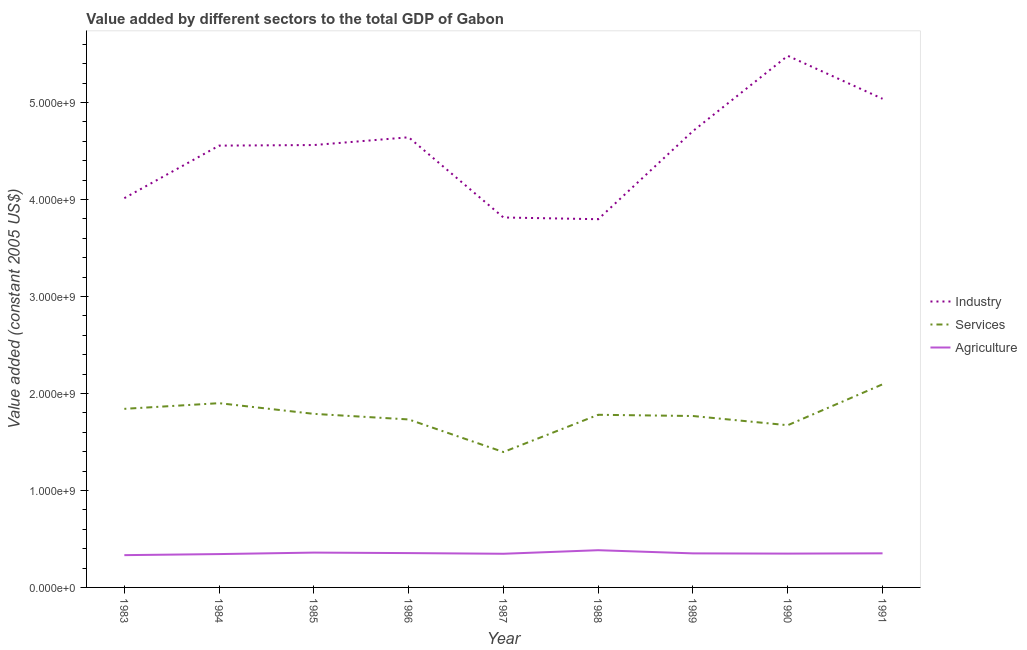How many different coloured lines are there?
Your answer should be compact. 3. What is the value added by services in 1984?
Your answer should be very brief. 1.90e+09. Across all years, what is the maximum value added by services?
Offer a terse response. 2.09e+09. Across all years, what is the minimum value added by industrial sector?
Offer a terse response. 3.80e+09. What is the total value added by services in the graph?
Keep it short and to the point. 1.60e+1. What is the difference between the value added by agricultural sector in 1983 and that in 1989?
Give a very brief answer. -1.82e+07. What is the difference between the value added by services in 1984 and the value added by agricultural sector in 1991?
Offer a terse response. 1.55e+09. What is the average value added by services per year?
Keep it short and to the point. 1.77e+09. In the year 1991, what is the difference between the value added by agricultural sector and value added by services?
Ensure brevity in your answer.  -1.74e+09. What is the ratio of the value added by agricultural sector in 1987 to that in 1989?
Make the answer very short. 0.99. Is the value added by agricultural sector in 1984 less than that in 1987?
Your answer should be compact. Yes. What is the difference between the highest and the second highest value added by services?
Your response must be concise. 1.95e+08. What is the difference between the highest and the lowest value added by agricultural sector?
Offer a very short reply. 5.08e+07. Is it the case that in every year, the sum of the value added by industrial sector and value added by services is greater than the value added by agricultural sector?
Give a very brief answer. Yes. Is the value added by services strictly greater than the value added by agricultural sector over the years?
Your response must be concise. Yes. Is the value added by industrial sector strictly less than the value added by agricultural sector over the years?
Keep it short and to the point. No. How many lines are there?
Give a very brief answer. 3. How many years are there in the graph?
Keep it short and to the point. 9. Does the graph contain grids?
Offer a very short reply. No. How many legend labels are there?
Offer a terse response. 3. What is the title of the graph?
Offer a very short reply. Value added by different sectors to the total GDP of Gabon. Does "Solid fuel" appear as one of the legend labels in the graph?
Provide a short and direct response. No. What is the label or title of the X-axis?
Provide a succinct answer. Year. What is the label or title of the Y-axis?
Offer a terse response. Value added (constant 2005 US$). What is the Value added (constant 2005 US$) in Industry in 1983?
Your response must be concise. 4.01e+09. What is the Value added (constant 2005 US$) of Services in 1983?
Offer a very short reply. 1.84e+09. What is the Value added (constant 2005 US$) in Agriculture in 1983?
Provide a short and direct response. 3.33e+08. What is the Value added (constant 2005 US$) in Industry in 1984?
Give a very brief answer. 4.56e+09. What is the Value added (constant 2005 US$) of Services in 1984?
Your answer should be very brief. 1.90e+09. What is the Value added (constant 2005 US$) in Agriculture in 1984?
Your response must be concise. 3.44e+08. What is the Value added (constant 2005 US$) of Industry in 1985?
Offer a terse response. 4.56e+09. What is the Value added (constant 2005 US$) of Services in 1985?
Your response must be concise. 1.79e+09. What is the Value added (constant 2005 US$) in Agriculture in 1985?
Provide a short and direct response. 3.59e+08. What is the Value added (constant 2005 US$) in Industry in 1986?
Your answer should be compact. 4.64e+09. What is the Value added (constant 2005 US$) in Services in 1986?
Your answer should be very brief. 1.73e+09. What is the Value added (constant 2005 US$) of Agriculture in 1986?
Keep it short and to the point. 3.54e+08. What is the Value added (constant 2005 US$) of Industry in 1987?
Your answer should be compact. 3.81e+09. What is the Value added (constant 2005 US$) of Services in 1987?
Offer a very short reply. 1.40e+09. What is the Value added (constant 2005 US$) in Agriculture in 1987?
Make the answer very short. 3.47e+08. What is the Value added (constant 2005 US$) in Industry in 1988?
Provide a short and direct response. 3.80e+09. What is the Value added (constant 2005 US$) of Services in 1988?
Make the answer very short. 1.78e+09. What is the Value added (constant 2005 US$) of Agriculture in 1988?
Offer a terse response. 3.84e+08. What is the Value added (constant 2005 US$) in Industry in 1989?
Provide a short and direct response. 4.71e+09. What is the Value added (constant 2005 US$) in Services in 1989?
Give a very brief answer. 1.77e+09. What is the Value added (constant 2005 US$) of Agriculture in 1989?
Your response must be concise. 3.51e+08. What is the Value added (constant 2005 US$) of Industry in 1990?
Ensure brevity in your answer.  5.48e+09. What is the Value added (constant 2005 US$) in Services in 1990?
Your response must be concise. 1.67e+09. What is the Value added (constant 2005 US$) in Agriculture in 1990?
Give a very brief answer. 3.49e+08. What is the Value added (constant 2005 US$) of Industry in 1991?
Ensure brevity in your answer.  5.04e+09. What is the Value added (constant 2005 US$) of Services in 1991?
Provide a short and direct response. 2.09e+09. What is the Value added (constant 2005 US$) in Agriculture in 1991?
Your answer should be compact. 3.52e+08. Across all years, what is the maximum Value added (constant 2005 US$) of Industry?
Provide a succinct answer. 5.48e+09. Across all years, what is the maximum Value added (constant 2005 US$) in Services?
Your answer should be very brief. 2.09e+09. Across all years, what is the maximum Value added (constant 2005 US$) of Agriculture?
Your response must be concise. 3.84e+08. Across all years, what is the minimum Value added (constant 2005 US$) in Industry?
Ensure brevity in your answer.  3.80e+09. Across all years, what is the minimum Value added (constant 2005 US$) of Services?
Offer a very short reply. 1.40e+09. Across all years, what is the minimum Value added (constant 2005 US$) of Agriculture?
Offer a very short reply. 3.33e+08. What is the total Value added (constant 2005 US$) in Industry in the graph?
Provide a short and direct response. 4.06e+1. What is the total Value added (constant 2005 US$) of Services in the graph?
Your answer should be very brief. 1.60e+1. What is the total Value added (constant 2005 US$) of Agriculture in the graph?
Your answer should be very brief. 3.17e+09. What is the difference between the Value added (constant 2005 US$) of Industry in 1983 and that in 1984?
Offer a terse response. -5.42e+08. What is the difference between the Value added (constant 2005 US$) in Services in 1983 and that in 1984?
Provide a short and direct response. -5.84e+07. What is the difference between the Value added (constant 2005 US$) in Agriculture in 1983 and that in 1984?
Ensure brevity in your answer.  -1.09e+07. What is the difference between the Value added (constant 2005 US$) of Industry in 1983 and that in 1985?
Give a very brief answer. -5.48e+08. What is the difference between the Value added (constant 2005 US$) in Services in 1983 and that in 1985?
Make the answer very short. 5.18e+07. What is the difference between the Value added (constant 2005 US$) in Agriculture in 1983 and that in 1985?
Your answer should be very brief. -2.63e+07. What is the difference between the Value added (constant 2005 US$) in Industry in 1983 and that in 1986?
Keep it short and to the point. -6.28e+08. What is the difference between the Value added (constant 2005 US$) in Services in 1983 and that in 1986?
Offer a terse response. 1.09e+08. What is the difference between the Value added (constant 2005 US$) in Agriculture in 1983 and that in 1986?
Your response must be concise. -2.12e+07. What is the difference between the Value added (constant 2005 US$) in Industry in 1983 and that in 1987?
Provide a succinct answer. 1.99e+08. What is the difference between the Value added (constant 2005 US$) of Services in 1983 and that in 1987?
Your answer should be very brief. 4.45e+08. What is the difference between the Value added (constant 2005 US$) of Agriculture in 1983 and that in 1987?
Give a very brief answer. -1.42e+07. What is the difference between the Value added (constant 2005 US$) of Industry in 1983 and that in 1988?
Provide a short and direct response. 2.17e+08. What is the difference between the Value added (constant 2005 US$) in Services in 1983 and that in 1988?
Give a very brief answer. 6.13e+07. What is the difference between the Value added (constant 2005 US$) of Agriculture in 1983 and that in 1988?
Keep it short and to the point. -5.08e+07. What is the difference between the Value added (constant 2005 US$) of Industry in 1983 and that in 1989?
Offer a very short reply. -6.92e+08. What is the difference between the Value added (constant 2005 US$) of Services in 1983 and that in 1989?
Your response must be concise. 7.39e+07. What is the difference between the Value added (constant 2005 US$) in Agriculture in 1983 and that in 1989?
Offer a terse response. -1.82e+07. What is the difference between the Value added (constant 2005 US$) in Industry in 1983 and that in 1990?
Provide a short and direct response. -1.47e+09. What is the difference between the Value added (constant 2005 US$) of Services in 1983 and that in 1990?
Offer a very short reply. 1.69e+08. What is the difference between the Value added (constant 2005 US$) of Agriculture in 1983 and that in 1990?
Your answer should be compact. -1.57e+07. What is the difference between the Value added (constant 2005 US$) in Industry in 1983 and that in 1991?
Provide a succinct answer. -1.02e+09. What is the difference between the Value added (constant 2005 US$) in Services in 1983 and that in 1991?
Ensure brevity in your answer.  -2.53e+08. What is the difference between the Value added (constant 2005 US$) of Agriculture in 1983 and that in 1991?
Your answer should be compact. -1.88e+07. What is the difference between the Value added (constant 2005 US$) in Industry in 1984 and that in 1985?
Provide a short and direct response. -5.93e+06. What is the difference between the Value added (constant 2005 US$) in Services in 1984 and that in 1985?
Ensure brevity in your answer.  1.10e+08. What is the difference between the Value added (constant 2005 US$) in Agriculture in 1984 and that in 1985?
Your answer should be compact. -1.54e+07. What is the difference between the Value added (constant 2005 US$) in Industry in 1984 and that in 1986?
Ensure brevity in your answer.  -8.60e+07. What is the difference between the Value added (constant 2005 US$) of Services in 1984 and that in 1986?
Your response must be concise. 1.68e+08. What is the difference between the Value added (constant 2005 US$) of Agriculture in 1984 and that in 1986?
Provide a succinct answer. -1.03e+07. What is the difference between the Value added (constant 2005 US$) of Industry in 1984 and that in 1987?
Make the answer very short. 7.41e+08. What is the difference between the Value added (constant 2005 US$) in Services in 1984 and that in 1987?
Offer a terse response. 5.04e+08. What is the difference between the Value added (constant 2005 US$) in Agriculture in 1984 and that in 1987?
Your response must be concise. -3.33e+06. What is the difference between the Value added (constant 2005 US$) of Industry in 1984 and that in 1988?
Provide a short and direct response. 7.59e+08. What is the difference between the Value added (constant 2005 US$) of Services in 1984 and that in 1988?
Ensure brevity in your answer.  1.20e+08. What is the difference between the Value added (constant 2005 US$) in Agriculture in 1984 and that in 1988?
Your answer should be compact. -4.00e+07. What is the difference between the Value added (constant 2005 US$) of Industry in 1984 and that in 1989?
Offer a very short reply. -1.50e+08. What is the difference between the Value added (constant 2005 US$) in Services in 1984 and that in 1989?
Your answer should be compact. 1.32e+08. What is the difference between the Value added (constant 2005 US$) of Agriculture in 1984 and that in 1989?
Provide a short and direct response. -7.26e+06. What is the difference between the Value added (constant 2005 US$) in Industry in 1984 and that in 1990?
Your answer should be compact. -9.26e+08. What is the difference between the Value added (constant 2005 US$) of Services in 1984 and that in 1990?
Ensure brevity in your answer.  2.27e+08. What is the difference between the Value added (constant 2005 US$) in Agriculture in 1984 and that in 1990?
Make the answer very short. -4.84e+06. What is the difference between the Value added (constant 2005 US$) in Industry in 1984 and that in 1991?
Offer a terse response. -4.83e+08. What is the difference between the Value added (constant 2005 US$) of Services in 1984 and that in 1991?
Your response must be concise. -1.95e+08. What is the difference between the Value added (constant 2005 US$) in Agriculture in 1984 and that in 1991?
Make the answer very short. -7.87e+06. What is the difference between the Value added (constant 2005 US$) of Industry in 1985 and that in 1986?
Make the answer very short. -8.00e+07. What is the difference between the Value added (constant 2005 US$) of Services in 1985 and that in 1986?
Make the answer very short. 5.75e+07. What is the difference between the Value added (constant 2005 US$) in Agriculture in 1985 and that in 1986?
Offer a terse response. 5.15e+06. What is the difference between the Value added (constant 2005 US$) in Industry in 1985 and that in 1987?
Provide a succinct answer. 7.47e+08. What is the difference between the Value added (constant 2005 US$) of Services in 1985 and that in 1987?
Offer a terse response. 3.94e+08. What is the difference between the Value added (constant 2005 US$) in Agriculture in 1985 and that in 1987?
Your response must be concise. 1.21e+07. What is the difference between the Value added (constant 2005 US$) in Industry in 1985 and that in 1988?
Make the answer very short. 7.65e+08. What is the difference between the Value added (constant 2005 US$) in Services in 1985 and that in 1988?
Keep it short and to the point. 9.49e+06. What is the difference between the Value added (constant 2005 US$) of Agriculture in 1985 and that in 1988?
Give a very brief answer. -2.45e+07. What is the difference between the Value added (constant 2005 US$) in Industry in 1985 and that in 1989?
Provide a short and direct response. -1.45e+08. What is the difference between the Value added (constant 2005 US$) in Services in 1985 and that in 1989?
Your answer should be compact. 2.22e+07. What is the difference between the Value added (constant 2005 US$) in Agriculture in 1985 and that in 1989?
Give a very brief answer. 8.17e+06. What is the difference between the Value added (constant 2005 US$) in Industry in 1985 and that in 1990?
Offer a very short reply. -9.20e+08. What is the difference between the Value added (constant 2005 US$) in Services in 1985 and that in 1990?
Provide a short and direct response. 1.17e+08. What is the difference between the Value added (constant 2005 US$) of Agriculture in 1985 and that in 1990?
Your response must be concise. 1.06e+07. What is the difference between the Value added (constant 2005 US$) in Industry in 1985 and that in 1991?
Ensure brevity in your answer.  -4.77e+08. What is the difference between the Value added (constant 2005 US$) of Services in 1985 and that in 1991?
Provide a succinct answer. -3.05e+08. What is the difference between the Value added (constant 2005 US$) of Agriculture in 1985 and that in 1991?
Your response must be concise. 7.57e+06. What is the difference between the Value added (constant 2005 US$) in Industry in 1986 and that in 1987?
Your response must be concise. 8.27e+08. What is the difference between the Value added (constant 2005 US$) in Services in 1986 and that in 1987?
Give a very brief answer. 3.36e+08. What is the difference between the Value added (constant 2005 US$) in Agriculture in 1986 and that in 1987?
Give a very brief answer. 6.96e+06. What is the difference between the Value added (constant 2005 US$) of Industry in 1986 and that in 1988?
Give a very brief answer. 8.45e+08. What is the difference between the Value added (constant 2005 US$) of Services in 1986 and that in 1988?
Provide a succinct answer. -4.80e+07. What is the difference between the Value added (constant 2005 US$) of Agriculture in 1986 and that in 1988?
Give a very brief answer. -2.97e+07. What is the difference between the Value added (constant 2005 US$) in Industry in 1986 and that in 1989?
Your answer should be compact. -6.45e+07. What is the difference between the Value added (constant 2005 US$) in Services in 1986 and that in 1989?
Make the answer very short. -3.54e+07. What is the difference between the Value added (constant 2005 US$) in Agriculture in 1986 and that in 1989?
Your response must be concise. 3.03e+06. What is the difference between the Value added (constant 2005 US$) in Industry in 1986 and that in 1990?
Give a very brief answer. -8.40e+08. What is the difference between the Value added (constant 2005 US$) of Services in 1986 and that in 1990?
Give a very brief answer. 5.96e+07. What is the difference between the Value added (constant 2005 US$) in Agriculture in 1986 and that in 1990?
Your answer should be compact. 5.45e+06. What is the difference between the Value added (constant 2005 US$) in Industry in 1986 and that in 1991?
Provide a short and direct response. -3.97e+08. What is the difference between the Value added (constant 2005 US$) in Services in 1986 and that in 1991?
Provide a succinct answer. -3.62e+08. What is the difference between the Value added (constant 2005 US$) in Agriculture in 1986 and that in 1991?
Keep it short and to the point. 2.42e+06. What is the difference between the Value added (constant 2005 US$) in Industry in 1987 and that in 1988?
Make the answer very short. 1.78e+07. What is the difference between the Value added (constant 2005 US$) of Services in 1987 and that in 1988?
Offer a terse response. -3.84e+08. What is the difference between the Value added (constant 2005 US$) in Agriculture in 1987 and that in 1988?
Offer a very short reply. -3.66e+07. What is the difference between the Value added (constant 2005 US$) in Industry in 1987 and that in 1989?
Provide a succinct answer. -8.91e+08. What is the difference between the Value added (constant 2005 US$) of Services in 1987 and that in 1989?
Give a very brief answer. -3.71e+08. What is the difference between the Value added (constant 2005 US$) of Agriculture in 1987 and that in 1989?
Keep it short and to the point. -3.93e+06. What is the difference between the Value added (constant 2005 US$) of Industry in 1987 and that in 1990?
Provide a short and direct response. -1.67e+09. What is the difference between the Value added (constant 2005 US$) of Services in 1987 and that in 1990?
Offer a terse response. -2.76e+08. What is the difference between the Value added (constant 2005 US$) of Agriculture in 1987 and that in 1990?
Make the answer very short. -1.51e+06. What is the difference between the Value added (constant 2005 US$) of Industry in 1987 and that in 1991?
Offer a terse response. -1.22e+09. What is the difference between the Value added (constant 2005 US$) of Services in 1987 and that in 1991?
Offer a very short reply. -6.98e+08. What is the difference between the Value added (constant 2005 US$) in Agriculture in 1987 and that in 1991?
Ensure brevity in your answer.  -4.54e+06. What is the difference between the Value added (constant 2005 US$) of Industry in 1988 and that in 1989?
Ensure brevity in your answer.  -9.09e+08. What is the difference between the Value added (constant 2005 US$) in Services in 1988 and that in 1989?
Keep it short and to the point. 1.27e+07. What is the difference between the Value added (constant 2005 US$) of Agriculture in 1988 and that in 1989?
Offer a terse response. 3.27e+07. What is the difference between the Value added (constant 2005 US$) of Industry in 1988 and that in 1990?
Your response must be concise. -1.69e+09. What is the difference between the Value added (constant 2005 US$) in Services in 1988 and that in 1990?
Provide a succinct answer. 1.08e+08. What is the difference between the Value added (constant 2005 US$) of Agriculture in 1988 and that in 1990?
Offer a terse response. 3.51e+07. What is the difference between the Value added (constant 2005 US$) of Industry in 1988 and that in 1991?
Ensure brevity in your answer.  -1.24e+09. What is the difference between the Value added (constant 2005 US$) in Services in 1988 and that in 1991?
Your answer should be very brief. -3.14e+08. What is the difference between the Value added (constant 2005 US$) in Agriculture in 1988 and that in 1991?
Offer a terse response. 3.21e+07. What is the difference between the Value added (constant 2005 US$) in Industry in 1989 and that in 1990?
Ensure brevity in your answer.  -7.76e+08. What is the difference between the Value added (constant 2005 US$) in Services in 1989 and that in 1990?
Offer a terse response. 9.49e+07. What is the difference between the Value added (constant 2005 US$) in Agriculture in 1989 and that in 1990?
Your answer should be very brief. 2.42e+06. What is the difference between the Value added (constant 2005 US$) of Industry in 1989 and that in 1991?
Your answer should be very brief. -3.33e+08. What is the difference between the Value added (constant 2005 US$) of Services in 1989 and that in 1991?
Keep it short and to the point. -3.27e+08. What is the difference between the Value added (constant 2005 US$) in Agriculture in 1989 and that in 1991?
Your answer should be compact. -6.05e+05. What is the difference between the Value added (constant 2005 US$) in Industry in 1990 and that in 1991?
Give a very brief answer. 4.43e+08. What is the difference between the Value added (constant 2005 US$) in Services in 1990 and that in 1991?
Offer a very short reply. -4.22e+08. What is the difference between the Value added (constant 2005 US$) of Agriculture in 1990 and that in 1991?
Give a very brief answer. -3.03e+06. What is the difference between the Value added (constant 2005 US$) in Industry in 1983 and the Value added (constant 2005 US$) in Services in 1984?
Give a very brief answer. 2.11e+09. What is the difference between the Value added (constant 2005 US$) of Industry in 1983 and the Value added (constant 2005 US$) of Agriculture in 1984?
Make the answer very short. 3.67e+09. What is the difference between the Value added (constant 2005 US$) in Services in 1983 and the Value added (constant 2005 US$) in Agriculture in 1984?
Provide a short and direct response. 1.50e+09. What is the difference between the Value added (constant 2005 US$) in Industry in 1983 and the Value added (constant 2005 US$) in Services in 1985?
Your answer should be compact. 2.22e+09. What is the difference between the Value added (constant 2005 US$) in Industry in 1983 and the Value added (constant 2005 US$) in Agriculture in 1985?
Ensure brevity in your answer.  3.65e+09. What is the difference between the Value added (constant 2005 US$) in Services in 1983 and the Value added (constant 2005 US$) in Agriculture in 1985?
Make the answer very short. 1.48e+09. What is the difference between the Value added (constant 2005 US$) in Industry in 1983 and the Value added (constant 2005 US$) in Services in 1986?
Your response must be concise. 2.28e+09. What is the difference between the Value added (constant 2005 US$) of Industry in 1983 and the Value added (constant 2005 US$) of Agriculture in 1986?
Provide a succinct answer. 3.66e+09. What is the difference between the Value added (constant 2005 US$) of Services in 1983 and the Value added (constant 2005 US$) of Agriculture in 1986?
Your answer should be compact. 1.49e+09. What is the difference between the Value added (constant 2005 US$) in Industry in 1983 and the Value added (constant 2005 US$) in Services in 1987?
Your answer should be very brief. 2.62e+09. What is the difference between the Value added (constant 2005 US$) of Industry in 1983 and the Value added (constant 2005 US$) of Agriculture in 1987?
Your answer should be very brief. 3.67e+09. What is the difference between the Value added (constant 2005 US$) in Services in 1983 and the Value added (constant 2005 US$) in Agriculture in 1987?
Your answer should be compact. 1.49e+09. What is the difference between the Value added (constant 2005 US$) of Industry in 1983 and the Value added (constant 2005 US$) of Services in 1988?
Your response must be concise. 2.23e+09. What is the difference between the Value added (constant 2005 US$) in Industry in 1983 and the Value added (constant 2005 US$) in Agriculture in 1988?
Offer a terse response. 3.63e+09. What is the difference between the Value added (constant 2005 US$) of Services in 1983 and the Value added (constant 2005 US$) of Agriculture in 1988?
Provide a short and direct response. 1.46e+09. What is the difference between the Value added (constant 2005 US$) in Industry in 1983 and the Value added (constant 2005 US$) in Services in 1989?
Make the answer very short. 2.25e+09. What is the difference between the Value added (constant 2005 US$) of Industry in 1983 and the Value added (constant 2005 US$) of Agriculture in 1989?
Your response must be concise. 3.66e+09. What is the difference between the Value added (constant 2005 US$) of Services in 1983 and the Value added (constant 2005 US$) of Agriculture in 1989?
Provide a succinct answer. 1.49e+09. What is the difference between the Value added (constant 2005 US$) in Industry in 1983 and the Value added (constant 2005 US$) in Services in 1990?
Your answer should be very brief. 2.34e+09. What is the difference between the Value added (constant 2005 US$) in Industry in 1983 and the Value added (constant 2005 US$) in Agriculture in 1990?
Make the answer very short. 3.67e+09. What is the difference between the Value added (constant 2005 US$) of Services in 1983 and the Value added (constant 2005 US$) of Agriculture in 1990?
Offer a terse response. 1.49e+09. What is the difference between the Value added (constant 2005 US$) in Industry in 1983 and the Value added (constant 2005 US$) in Services in 1991?
Provide a short and direct response. 1.92e+09. What is the difference between the Value added (constant 2005 US$) in Industry in 1983 and the Value added (constant 2005 US$) in Agriculture in 1991?
Give a very brief answer. 3.66e+09. What is the difference between the Value added (constant 2005 US$) in Services in 1983 and the Value added (constant 2005 US$) in Agriculture in 1991?
Ensure brevity in your answer.  1.49e+09. What is the difference between the Value added (constant 2005 US$) of Industry in 1984 and the Value added (constant 2005 US$) of Services in 1985?
Offer a very short reply. 2.77e+09. What is the difference between the Value added (constant 2005 US$) of Industry in 1984 and the Value added (constant 2005 US$) of Agriculture in 1985?
Ensure brevity in your answer.  4.20e+09. What is the difference between the Value added (constant 2005 US$) in Services in 1984 and the Value added (constant 2005 US$) in Agriculture in 1985?
Make the answer very short. 1.54e+09. What is the difference between the Value added (constant 2005 US$) in Industry in 1984 and the Value added (constant 2005 US$) in Services in 1986?
Provide a succinct answer. 2.82e+09. What is the difference between the Value added (constant 2005 US$) of Industry in 1984 and the Value added (constant 2005 US$) of Agriculture in 1986?
Your response must be concise. 4.20e+09. What is the difference between the Value added (constant 2005 US$) of Services in 1984 and the Value added (constant 2005 US$) of Agriculture in 1986?
Ensure brevity in your answer.  1.55e+09. What is the difference between the Value added (constant 2005 US$) of Industry in 1984 and the Value added (constant 2005 US$) of Services in 1987?
Give a very brief answer. 3.16e+09. What is the difference between the Value added (constant 2005 US$) of Industry in 1984 and the Value added (constant 2005 US$) of Agriculture in 1987?
Ensure brevity in your answer.  4.21e+09. What is the difference between the Value added (constant 2005 US$) of Services in 1984 and the Value added (constant 2005 US$) of Agriculture in 1987?
Your response must be concise. 1.55e+09. What is the difference between the Value added (constant 2005 US$) of Industry in 1984 and the Value added (constant 2005 US$) of Services in 1988?
Your answer should be compact. 2.78e+09. What is the difference between the Value added (constant 2005 US$) in Industry in 1984 and the Value added (constant 2005 US$) in Agriculture in 1988?
Offer a terse response. 4.17e+09. What is the difference between the Value added (constant 2005 US$) of Services in 1984 and the Value added (constant 2005 US$) of Agriculture in 1988?
Your answer should be compact. 1.52e+09. What is the difference between the Value added (constant 2005 US$) in Industry in 1984 and the Value added (constant 2005 US$) in Services in 1989?
Your answer should be compact. 2.79e+09. What is the difference between the Value added (constant 2005 US$) in Industry in 1984 and the Value added (constant 2005 US$) in Agriculture in 1989?
Provide a short and direct response. 4.20e+09. What is the difference between the Value added (constant 2005 US$) in Services in 1984 and the Value added (constant 2005 US$) in Agriculture in 1989?
Offer a very short reply. 1.55e+09. What is the difference between the Value added (constant 2005 US$) of Industry in 1984 and the Value added (constant 2005 US$) of Services in 1990?
Your answer should be compact. 2.88e+09. What is the difference between the Value added (constant 2005 US$) in Industry in 1984 and the Value added (constant 2005 US$) in Agriculture in 1990?
Your response must be concise. 4.21e+09. What is the difference between the Value added (constant 2005 US$) of Services in 1984 and the Value added (constant 2005 US$) of Agriculture in 1990?
Provide a succinct answer. 1.55e+09. What is the difference between the Value added (constant 2005 US$) of Industry in 1984 and the Value added (constant 2005 US$) of Services in 1991?
Your answer should be compact. 2.46e+09. What is the difference between the Value added (constant 2005 US$) of Industry in 1984 and the Value added (constant 2005 US$) of Agriculture in 1991?
Your response must be concise. 4.20e+09. What is the difference between the Value added (constant 2005 US$) in Services in 1984 and the Value added (constant 2005 US$) in Agriculture in 1991?
Your answer should be very brief. 1.55e+09. What is the difference between the Value added (constant 2005 US$) in Industry in 1985 and the Value added (constant 2005 US$) in Services in 1986?
Offer a terse response. 2.83e+09. What is the difference between the Value added (constant 2005 US$) in Industry in 1985 and the Value added (constant 2005 US$) in Agriculture in 1986?
Ensure brevity in your answer.  4.21e+09. What is the difference between the Value added (constant 2005 US$) in Services in 1985 and the Value added (constant 2005 US$) in Agriculture in 1986?
Make the answer very short. 1.44e+09. What is the difference between the Value added (constant 2005 US$) of Industry in 1985 and the Value added (constant 2005 US$) of Services in 1987?
Your response must be concise. 3.17e+09. What is the difference between the Value added (constant 2005 US$) of Industry in 1985 and the Value added (constant 2005 US$) of Agriculture in 1987?
Provide a short and direct response. 4.21e+09. What is the difference between the Value added (constant 2005 US$) in Services in 1985 and the Value added (constant 2005 US$) in Agriculture in 1987?
Provide a succinct answer. 1.44e+09. What is the difference between the Value added (constant 2005 US$) in Industry in 1985 and the Value added (constant 2005 US$) in Services in 1988?
Your response must be concise. 2.78e+09. What is the difference between the Value added (constant 2005 US$) of Industry in 1985 and the Value added (constant 2005 US$) of Agriculture in 1988?
Provide a succinct answer. 4.18e+09. What is the difference between the Value added (constant 2005 US$) in Services in 1985 and the Value added (constant 2005 US$) in Agriculture in 1988?
Provide a succinct answer. 1.41e+09. What is the difference between the Value added (constant 2005 US$) in Industry in 1985 and the Value added (constant 2005 US$) in Services in 1989?
Keep it short and to the point. 2.79e+09. What is the difference between the Value added (constant 2005 US$) of Industry in 1985 and the Value added (constant 2005 US$) of Agriculture in 1989?
Keep it short and to the point. 4.21e+09. What is the difference between the Value added (constant 2005 US$) in Services in 1985 and the Value added (constant 2005 US$) in Agriculture in 1989?
Provide a short and direct response. 1.44e+09. What is the difference between the Value added (constant 2005 US$) in Industry in 1985 and the Value added (constant 2005 US$) in Services in 1990?
Your response must be concise. 2.89e+09. What is the difference between the Value added (constant 2005 US$) of Industry in 1985 and the Value added (constant 2005 US$) of Agriculture in 1990?
Offer a terse response. 4.21e+09. What is the difference between the Value added (constant 2005 US$) of Services in 1985 and the Value added (constant 2005 US$) of Agriculture in 1990?
Offer a very short reply. 1.44e+09. What is the difference between the Value added (constant 2005 US$) in Industry in 1985 and the Value added (constant 2005 US$) in Services in 1991?
Keep it short and to the point. 2.47e+09. What is the difference between the Value added (constant 2005 US$) of Industry in 1985 and the Value added (constant 2005 US$) of Agriculture in 1991?
Keep it short and to the point. 4.21e+09. What is the difference between the Value added (constant 2005 US$) of Services in 1985 and the Value added (constant 2005 US$) of Agriculture in 1991?
Ensure brevity in your answer.  1.44e+09. What is the difference between the Value added (constant 2005 US$) of Industry in 1986 and the Value added (constant 2005 US$) of Services in 1987?
Your answer should be compact. 3.25e+09. What is the difference between the Value added (constant 2005 US$) of Industry in 1986 and the Value added (constant 2005 US$) of Agriculture in 1987?
Your answer should be very brief. 4.29e+09. What is the difference between the Value added (constant 2005 US$) of Services in 1986 and the Value added (constant 2005 US$) of Agriculture in 1987?
Offer a terse response. 1.39e+09. What is the difference between the Value added (constant 2005 US$) in Industry in 1986 and the Value added (constant 2005 US$) in Services in 1988?
Your answer should be very brief. 2.86e+09. What is the difference between the Value added (constant 2005 US$) in Industry in 1986 and the Value added (constant 2005 US$) in Agriculture in 1988?
Your answer should be very brief. 4.26e+09. What is the difference between the Value added (constant 2005 US$) of Services in 1986 and the Value added (constant 2005 US$) of Agriculture in 1988?
Make the answer very short. 1.35e+09. What is the difference between the Value added (constant 2005 US$) of Industry in 1986 and the Value added (constant 2005 US$) of Services in 1989?
Ensure brevity in your answer.  2.87e+09. What is the difference between the Value added (constant 2005 US$) of Industry in 1986 and the Value added (constant 2005 US$) of Agriculture in 1989?
Give a very brief answer. 4.29e+09. What is the difference between the Value added (constant 2005 US$) in Services in 1986 and the Value added (constant 2005 US$) in Agriculture in 1989?
Ensure brevity in your answer.  1.38e+09. What is the difference between the Value added (constant 2005 US$) of Industry in 1986 and the Value added (constant 2005 US$) of Services in 1990?
Your answer should be compact. 2.97e+09. What is the difference between the Value added (constant 2005 US$) in Industry in 1986 and the Value added (constant 2005 US$) in Agriculture in 1990?
Offer a very short reply. 4.29e+09. What is the difference between the Value added (constant 2005 US$) in Services in 1986 and the Value added (constant 2005 US$) in Agriculture in 1990?
Your answer should be very brief. 1.38e+09. What is the difference between the Value added (constant 2005 US$) in Industry in 1986 and the Value added (constant 2005 US$) in Services in 1991?
Your answer should be compact. 2.55e+09. What is the difference between the Value added (constant 2005 US$) of Industry in 1986 and the Value added (constant 2005 US$) of Agriculture in 1991?
Your answer should be compact. 4.29e+09. What is the difference between the Value added (constant 2005 US$) of Services in 1986 and the Value added (constant 2005 US$) of Agriculture in 1991?
Offer a very short reply. 1.38e+09. What is the difference between the Value added (constant 2005 US$) of Industry in 1987 and the Value added (constant 2005 US$) of Services in 1988?
Your answer should be very brief. 2.03e+09. What is the difference between the Value added (constant 2005 US$) of Industry in 1987 and the Value added (constant 2005 US$) of Agriculture in 1988?
Offer a terse response. 3.43e+09. What is the difference between the Value added (constant 2005 US$) in Services in 1987 and the Value added (constant 2005 US$) in Agriculture in 1988?
Offer a terse response. 1.01e+09. What is the difference between the Value added (constant 2005 US$) in Industry in 1987 and the Value added (constant 2005 US$) in Services in 1989?
Provide a succinct answer. 2.05e+09. What is the difference between the Value added (constant 2005 US$) in Industry in 1987 and the Value added (constant 2005 US$) in Agriculture in 1989?
Offer a very short reply. 3.46e+09. What is the difference between the Value added (constant 2005 US$) of Services in 1987 and the Value added (constant 2005 US$) of Agriculture in 1989?
Your response must be concise. 1.05e+09. What is the difference between the Value added (constant 2005 US$) in Industry in 1987 and the Value added (constant 2005 US$) in Services in 1990?
Give a very brief answer. 2.14e+09. What is the difference between the Value added (constant 2005 US$) in Industry in 1987 and the Value added (constant 2005 US$) in Agriculture in 1990?
Provide a succinct answer. 3.47e+09. What is the difference between the Value added (constant 2005 US$) of Services in 1987 and the Value added (constant 2005 US$) of Agriculture in 1990?
Give a very brief answer. 1.05e+09. What is the difference between the Value added (constant 2005 US$) of Industry in 1987 and the Value added (constant 2005 US$) of Services in 1991?
Keep it short and to the point. 1.72e+09. What is the difference between the Value added (constant 2005 US$) in Industry in 1987 and the Value added (constant 2005 US$) in Agriculture in 1991?
Make the answer very short. 3.46e+09. What is the difference between the Value added (constant 2005 US$) of Services in 1987 and the Value added (constant 2005 US$) of Agriculture in 1991?
Ensure brevity in your answer.  1.04e+09. What is the difference between the Value added (constant 2005 US$) of Industry in 1988 and the Value added (constant 2005 US$) of Services in 1989?
Your answer should be very brief. 2.03e+09. What is the difference between the Value added (constant 2005 US$) of Industry in 1988 and the Value added (constant 2005 US$) of Agriculture in 1989?
Your answer should be compact. 3.45e+09. What is the difference between the Value added (constant 2005 US$) in Services in 1988 and the Value added (constant 2005 US$) in Agriculture in 1989?
Make the answer very short. 1.43e+09. What is the difference between the Value added (constant 2005 US$) in Industry in 1988 and the Value added (constant 2005 US$) in Services in 1990?
Ensure brevity in your answer.  2.12e+09. What is the difference between the Value added (constant 2005 US$) of Industry in 1988 and the Value added (constant 2005 US$) of Agriculture in 1990?
Ensure brevity in your answer.  3.45e+09. What is the difference between the Value added (constant 2005 US$) in Services in 1988 and the Value added (constant 2005 US$) in Agriculture in 1990?
Make the answer very short. 1.43e+09. What is the difference between the Value added (constant 2005 US$) in Industry in 1988 and the Value added (constant 2005 US$) in Services in 1991?
Give a very brief answer. 1.70e+09. What is the difference between the Value added (constant 2005 US$) in Industry in 1988 and the Value added (constant 2005 US$) in Agriculture in 1991?
Keep it short and to the point. 3.45e+09. What is the difference between the Value added (constant 2005 US$) of Services in 1988 and the Value added (constant 2005 US$) of Agriculture in 1991?
Your response must be concise. 1.43e+09. What is the difference between the Value added (constant 2005 US$) of Industry in 1989 and the Value added (constant 2005 US$) of Services in 1990?
Provide a short and direct response. 3.03e+09. What is the difference between the Value added (constant 2005 US$) of Industry in 1989 and the Value added (constant 2005 US$) of Agriculture in 1990?
Your answer should be very brief. 4.36e+09. What is the difference between the Value added (constant 2005 US$) of Services in 1989 and the Value added (constant 2005 US$) of Agriculture in 1990?
Keep it short and to the point. 1.42e+09. What is the difference between the Value added (constant 2005 US$) of Industry in 1989 and the Value added (constant 2005 US$) of Services in 1991?
Provide a succinct answer. 2.61e+09. What is the difference between the Value added (constant 2005 US$) of Industry in 1989 and the Value added (constant 2005 US$) of Agriculture in 1991?
Your answer should be very brief. 4.35e+09. What is the difference between the Value added (constant 2005 US$) in Services in 1989 and the Value added (constant 2005 US$) in Agriculture in 1991?
Your response must be concise. 1.42e+09. What is the difference between the Value added (constant 2005 US$) in Industry in 1990 and the Value added (constant 2005 US$) in Services in 1991?
Your answer should be very brief. 3.39e+09. What is the difference between the Value added (constant 2005 US$) of Industry in 1990 and the Value added (constant 2005 US$) of Agriculture in 1991?
Ensure brevity in your answer.  5.13e+09. What is the difference between the Value added (constant 2005 US$) of Services in 1990 and the Value added (constant 2005 US$) of Agriculture in 1991?
Give a very brief answer. 1.32e+09. What is the average Value added (constant 2005 US$) in Industry per year?
Offer a terse response. 4.51e+09. What is the average Value added (constant 2005 US$) in Services per year?
Make the answer very short. 1.77e+09. What is the average Value added (constant 2005 US$) of Agriculture per year?
Ensure brevity in your answer.  3.52e+08. In the year 1983, what is the difference between the Value added (constant 2005 US$) of Industry and Value added (constant 2005 US$) of Services?
Provide a succinct answer. 2.17e+09. In the year 1983, what is the difference between the Value added (constant 2005 US$) in Industry and Value added (constant 2005 US$) in Agriculture?
Your answer should be compact. 3.68e+09. In the year 1983, what is the difference between the Value added (constant 2005 US$) of Services and Value added (constant 2005 US$) of Agriculture?
Offer a very short reply. 1.51e+09. In the year 1984, what is the difference between the Value added (constant 2005 US$) in Industry and Value added (constant 2005 US$) in Services?
Your response must be concise. 2.66e+09. In the year 1984, what is the difference between the Value added (constant 2005 US$) in Industry and Value added (constant 2005 US$) in Agriculture?
Your response must be concise. 4.21e+09. In the year 1984, what is the difference between the Value added (constant 2005 US$) in Services and Value added (constant 2005 US$) in Agriculture?
Keep it short and to the point. 1.56e+09. In the year 1985, what is the difference between the Value added (constant 2005 US$) in Industry and Value added (constant 2005 US$) in Services?
Offer a very short reply. 2.77e+09. In the year 1985, what is the difference between the Value added (constant 2005 US$) in Industry and Value added (constant 2005 US$) in Agriculture?
Keep it short and to the point. 4.20e+09. In the year 1985, what is the difference between the Value added (constant 2005 US$) in Services and Value added (constant 2005 US$) in Agriculture?
Make the answer very short. 1.43e+09. In the year 1986, what is the difference between the Value added (constant 2005 US$) in Industry and Value added (constant 2005 US$) in Services?
Provide a succinct answer. 2.91e+09. In the year 1986, what is the difference between the Value added (constant 2005 US$) of Industry and Value added (constant 2005 US$) of Agriculture?
Provide a short and direct response. 4.29e+09. In the year 1986, what is the difference between the Value added (constant 2005 US$) in Services and Value added (constant 2005 US$) in Agriculture?
Your answer should be compact. 1.38e+09. In the year 1987, what is the difference between the Value added (constant 2005 US$) in Industry and Value added (constant 2005 US$) in Services?
Offer a very short reply. 2.42e+09. In the year 1987, what is the difference between the Value added (constant 2005 US$) of Industry and Value added (constant 2005 US$) of Agriculture?
Offer a very short reply. 3.47e+09. In the year 1987, what is the difference between the Value added (constant 2005 US$) in Services and Value added (constant 2005 US$) in Agriculture?
Offer a very short reply. 1.05e+09. In the year 1988, what is the difference between the Value added (constant 2005 US$) of Industry and Value added (constant 2005 US$) of Services?
Provide a succinct answer. 2.02e+09. In the year 1988, what is the difference between the Value added (constant 2005 US$) in Industry and Value added (constant 2005 US$) in Agriculture?
Your answer should be very brief. 3.41e+09. In the year 1988, what is the difference between the Value added (constant 2005 US$) of Services and Value added (constant 2005 US$) of Agriculture?
Your answer should be very brief. 1.40e+09. In the year 1989, what is the difference between the Value added (constant 2005 US$) in Industry and Value added (constant 2005 US$) in Services?
Provide a succinct answer. 2.94e+09. In the year 1989, what is the difference between the Value added (constant 2005 US$) of Industry and Value added (constant 2005 US$) of Agriculture?
Your answer should be compact. 4.36e+09. In the year 1989, what is the difference between the Value added (constant 2005 US$) in Services and Value added (constant 2005 US$) in Agriculture?
Your response must be concise. 1.42e+09. In the year 1990, what is the difference between the Value added (constant 2005 US$) of Industry and Value added (constant 2005 US$) of Services?
Give a very brief answer. 3.81e+09. In the year 1990, what is the difference between the Value added (constant 2005 US$) in Industry and Value added (constant 2005 US$) in Agriculture?
Give a very brief answer. 5.13e+09. In the year 1990, what is the difference between the Value added (constant 2005 US$) of Services and Value added (constant 2005 US$) of Agriculture?
Your response must be concise. 1.32e+09. In the year 1991, what is the difference between the Value added (constant 2005 US$) of Industry and Value added (constant 2005 US$) of Services?
Your response must be concise. 2.94e+09. In the year 1991, what is the difference between the Value added (constant 2005 US$) in Industry and Value added (constant 2005 US$) in Agriculture?
Provide a succinct answer. 4.69e+09. In the year 1991, what is the difference between the Value added (constant 2005 US$) in Services and Value added (constant 2005 US$) in Agriculture?
Offer a very short reply. 1.74e+09. What is the ratio of the Value added (constant 2005 US$) in Industry in 1983 to that in 1984?
Provide a succinct answer. 0.88. What is the ratio of the Value added (constant 2005 US$) of Services in 1983 to that in 1984?
Your answer should be compact. 0.97. What is the ratio of the Value added (constant 2005 US$) of Agriculture in 1983 to that in 1984?
Keep it short and to the point. 0.97. What is the ratio of the Value added (constant 2005 US$) in Services in 1983 to that in 1985?
Your answer should be very brief. 1.03. What is the ratio of the Value added (constant 2005 US$) in Agriculture in 1983 to that in 1985?
Give a very brief answer. 0.93. What is the ratio of the Value added (constant 2005 US$) in Industry in 1983 to that in 1986?
Your answer should be compact. 0.86. What is the ratio of the Value added (constant 2005 US$) in Services in 1983 to that in 1986?
Offer a terse response. 1.06. What is the ratio of the Value added (constant 2005 US$) in Agriculture in 1983 to that in 1986?
Provide a short and direct response. 0.94. What is the ratio of the Value added (constant 2005 US$) of Industry in 1983 to that in 1987?
Provide a succinct answer. 1.05. What is the ratio of the Value added (constant 2005 US$) of Services in 1983 to that in 1987?
Ensure brevity in your answer.  1.32. What is the ratio of the Value added (constant 2005 US$) in Industry in 1983 to that in 1988?
Your answer should be very brief. 1.06. What is the ratio of the Value added (constant 2005 US$) in Services in 1983 to that in 1988?
Keep it short and to the point. 1.03. What is the ratio of the Value added (constant 2005 US$) in Agriculture in 1983 to that in 1988?
Provide a succinct answer. 0.87. What is the ratio of the Value added (constant 2005 US$) of Industry in 1983 to that in 1989?
Ensure brevity in your answer.  0.85. What is the ratio of the Value added (constant 2005 US$) in Services in 1983 to that in 1989?
Provide a short and direct response. 1.04. What is the ratio of the Value added (constant 2005 US$) in Agriculture in 1983 to that in 1989?
Offer a terse response. 0.95. What is the ratio of the Value added (constant 2005 US$) in Industry in 1983 to that in 1990?
Ensure brevity in your answer.  0.73. What is the ratio of the Value added (constant 2005 US$) of Services in 1983 to that in 1990?
Make the answer very short. 1.1. What is the ratio of the Value added (constant 2005 US$) in Agriculture in 1983 to that in 1990?
Provide a short and direct response. 0.95. What is the ratio of the Value added (constant 2005 US$) in Industry in 1983 to that in 1991?
Offer a terse response. 0.8. What is the ratio of the Value added (constant 2005 US$) in Services in 1983 to that in 1991?
Your answer should be compact. 0.88. What is the ratio of the Value added (constant 2005 US$) in Agriculture in 1983 to that in 1991?
Keep it short and to the point. 0.95. What is the ratio of the Value added (constant 2005 US$) in Services in 1984 to that in 1985?
Ensure brevity in your answer.  1.06. What is the ratio of the Value added (constant 2005 US$) in Industry in 1984 to that in 1986?
Provide a succinct answer. 0.98. What is the ratio of the Value added (constant 2005 US$) in Services in 1984 to that in 1986?
Your answer should be compact. 1.1. What is the ratio of the Value added (constant 2005 US$) in Agriculture in 1984 to that in 1986?
Your response must be concise. 0.97. What is the ratio of the Value added (constant 2005 US$) in Industry in 1984 to that in 1987?
Provide a short and direct response. 1.19. What is the ratio of the Value added (constant 2005 US$) of Services in 1984 to that in 1987?
Offer a very short reply. 1.36. What is the ratio of the Value added (constant 2005 US$) in Industry in 1984 to that in 1988?
Your answer should be very brief. 1.2. What is the ratio of the Value added (constant 2005 US$) in Services in 1984 to that in 1988?
Your answer should be compact. 1.07. What is the ratio of the Value added (constant 2005 US$) of Agriculture in 1984 to that in 1988?
Your response must be concise. 0.9. What is the ratio of the Value added (constant 2005 US$) in Industry in 1984 to that in 1989?
Ensure brevity in your answer.  0.97. What is the ratio of the Value added (constant 2005 US$) in Services in 1984 to that in 1989?
Your response must be concise. 1.07. What is the ratio of the Value added (constant 2005 US$) in Agriculture in 1984 to that in 1989?
Your response must be concise. 0.98. What is the ratio of the Value added (constant 2005 US$) in Industry in 1984 to that in 1990?
Offer a very short reply. 0.83. What is the ratio of the Value added (constant 2005 US$) in Services in 1984 to that in 1990?
Offer a terse response. 1.14. What is the ratio of the Value added (constant 2005 US$) of Agriculture in 1984 to that in 1990?
Provide a succinct answer. 0.99. What is the ratio of the Value added (constant 2005 US$) of Industry in 1984 to that in 1991?
Your answer should be very brief. 0.9. What is the ratio of the Value added (constant 2005 US$) in Services in 1984 to that in 1991?
Your response must be concise. 0.91. What is the ratio of the Value added (constant 2005 US$) in Agriculture in 1984 to that in 1991?
Provide a succinct answer. 0.98. What is the ratio of the Value added (constant 2005 US$) of Industry in 1985 to that in 1986?
Keep it short and to the point. 0.98. What is the ratio of the Value added (constant 2005 US$) in Services in 1985 to that in 1986?
Give a very brief answer. 1.03. What is the ratio of the Value added (constant 2005 US$) of Agriculture in 1985 to that in 1986?
Make the answer very short. 1.01. What is the ratio of the Value added (constant 2005 US$) of Industry in 1985 to that in 1987?
Offer a very short reply. 1.2. What is the ratio of the Value added (constant 2005 US$) in Services in 1985 to that in 1987?
Make the answer very short. 1.28. What is the ratio of the Value added (constant 2005 US$) of Agriculture in 1985 to that in 1987?
Keep it short and to the point. 1.03. What is the ratio of the Value added (constant 2005 US$) of Industry in 1985 to that in 1988?
Provide a succinct answer. 1.2. What is the ratio of the Value added (constant 2005 US$) of Services in 1985 to that in 1988?
Your answer should be very brief. 1.01. What is the ratio of the Value added (constant 2005 US$) of Agriculture in 1985 to that in 1988?
Give a very brief answer. 0.94. What is the ratio of the Value added (constant 2005 US$) of Industry in 1985 to that in 1989?
Your answer should be compact. 0.97. What is the ratio of the Value added (constant 2005 US$) of Services in 1985 to that in 1989?
Provide a succinct answer. 1.01. What is the ratio of the Value added (constant 2005 US$) in Agriculture in 1985 to that in 1989?
Provide a short and direct response. 1.02. What is the ratio of the Value added (constant 2005 US$) of Industry in 1985 to that in 1990?
Ensure brevity in your answer.  0.83. What is the ratio of the Value added (constant 2005 US$) of Services in 1985 to that in 1990?
Provide a short and direct response. 1.07. What is the ratio of the Value added (constant 2005 US$) in Agriculture in 1985 to that in 1990?
Ensure brevity in your answer.  1.03. What is the ratio of the Value added (constant 2005 US$) in Industry in 1985 to that in 1991?
Offer a very short reply. 0.91. What is the ratio of the Value added (constant 2005 US$) in Services in 1985 to that in 1991?
Your answer should be compact. 0.85. What is the ratio of the Value added (constant 2005 US$) of Agriculture in 1985 to that in 1991?
Provide a succinct answer. 1.02. What is the ratio of the Value added (constant 2005 US$) in Industry in 1986 to that in 1987?
Offer a terse response. 1.22. What is the ratio of the Value added (constant 2005 US$) in Services in 1986 to that in 1987?
Make the answer very short. 1.24. What is the ratio of the Value added (constant 2005 US$) of Agriculture in 1986 to that in 1987?
Provide a short and direct response. 1.02. What is the ratio of the Value added (constant 2005 US$) of Industry in 1986 to that in 1988?
Provide a succinct answer. 1.22. What is the ratio of the Value added (constant 2005 US$) in Services in 1986 to that in 1988?
Provide a succinct answer. 0.97. What is the ratio of the Value added (constant 2005 US$) of Agriculture in 1986 to that in 1988?
Provide a short and direct response. 0.92. What is the ratio of the Value added (constant 2005 US$) of Industry in 1986 to that in 1989?
Provide a short and direct response. 0.99. What is the ratio of the Value added (constant 2005 US$) in Agriculture in 1986 to that in 1989?
Make the answer very short. 1.01. What is the ratio of the Value added (constant 2005 US$) of Industry in 1986 to that in 1990?
Your response must be concise. 0.85. What is the ratio of the Value added (constant 2005 US$) in Services in 1986 to that in 1990?
Your response must be concise. 1.04. What is the ratio of the Value added (constant 2005 US$) of Agriculture in 1986 to that in 1990?
Offer a terse response. 1.02. What is the ratio of the Value added (constant 2005 US$) of Industry in 1986 to that in 1991?
Offer a very short reply. 0.92. What is the ratio of the Value added (constant 2005 US$) in Services in 1986 to that in 1991?
Ensure brevity in your answer.  0.83. What is the ratio of the Value added (constant 2005 US$) of Agriculture in 1986 to that in 1991?
Ensure brevity in your answer.  1.01. What is the ratio of the Value added (constant 2005 US$) of Industry in 1987 to that in 1988?
Make the answer very short. 1. What is the ratio of the Value added (constant 2005 US$) in Services in 1987 to that in 1988?
Provide a succinct answer. 0.78. What is the ratio of the Value added (constant 2005 US$) of Agriculture in 1987 to that in 1988?
Provide a short and direct response. 0.9. What is the ratio of the Value added (constant 2005 US$) of Industry in 1987 to that in 1989?
Your response must be concise. 0.81. What is the ratio of the Value added (constant 2005 US$) of Services in 1987 to that in 1989?
Make the answer very short. 0.79. What is the ratio of the Value added (constant 2005 US$) of Industry in 1987 to that in 1990?
Provide a succinct answer. 0.7. What is the ratio of the Value added (constant 2005 US$) of Services in 1987 to that in 1990?
Make the answer very short. 0.83. What is the ratio of the Value added (constant 2005 US$) in Industry in 1987 to that in 1991?
Your answer should be compact. 0.76. What is the ratio of the Value added (constant 2005 US$) of Services in 1987 to that in 1991?
Offer a very short reply. 0.67. What is the ratio of the Value added (constant 2005 US$) of Agriculture in 1987 to that in 1991?
Provide a succinct answer. 0.99. What is the ratio of the Value added (constant 2005 US$) of Industry in 1988 to that in 1989?
Offer a terse response. 0.81. What is the ratio of the Value added (constant 2005 US$) of Services in 1988 to that in 1989?
Your response must be concise. 1.01. What is the ratio of the Value added (constant 2005 US$) of Agriculture in 1988 to that in 1989?
Your response must be concise. 1.09. What is the ratio of the Value added (constant 2005 US$) in Industry in 1988 to that in 1990?
Ensure brevity in your answer.  0.69. What is the ratio of the Value added (constant 2005 US$) in Services in 1988 to that in 1990?
Your answer should be very brief. 1.06. What is the ratio of the Value added (constant 2005 US$) in Agriculture in 1988 to that in 1990?
Your response must be concise. 1.1. What is the ratio of the Value added (constant 2005 US$) of Industry in 1988 to that in 1991?
Your response must be concise. 0.75. What is the ratio of the Value added (constant 2005 US$) of Services in 1988 to that in 1991?
Give a very brief answer. 0.85. What is the ratio of the Value added (constant 2005 US$) in Agriculture in 1988 to that in 1991?
Your response must be concise. 1.09. What is the ratio of the Value added (constant 2005 US$) in Industry in 1989 to that in 1990?
Provide a short and direct response. 0.86. What is the ratio of the Value added (constant 2005 US$) in Services in 1989 to that in 1990?
Give a very brief answer. 1.06. What is the ratio of the Value added (constant 2005 US$) in Agriculture in 1989 to that in 1990?
Keep it short and to the point. 1.01. What is the ratio of the Value added (constant 2005 US$) in Industry in 1989 to that in 1991?
Offer a terse response. 0.93. What is the ratio of the Value added (constant 2005 US$) of Services in 1989 to that in 1991?
Keep it short and to the point. 0.84. What is the ratio of the Value added (constant 2005 US$) of Agriculture in 1989 to that in 1991?
Make the answer very short. 1. What is the ratio of the Value added (constant 2005 US$) in Industry in 1990 to that in 1991?
Ensure brevity in your answer.  1.09. What is the ratio of the Value added (constant 2005 US$) in Services in 1990 to that in 1991?
Ensure brevity in your answer.  0.8. What is the difference between the highest and the second highest Value added (constant 2005 US$) in Industry?
Keep it short and to the point. 4.43e+08. What is the difference between the highest and the second highest Value added (constant 2005 US$) of Services?
Your response must be concise. 1.95e+08. What is the difference between the highest and the second highest Value added (constant 2005 US$) of Agriculture?
Provide a short and direct response. 2.45e+07. What is the difference between the highest and the lowest Value added (constant 2005 US$) in Industry?
Offer a very short reply. 1.69e+09. What is the difference between the highest and the lowest Value added (constant 2005 US$) in Services?
Ensure brevity in your answer.  6.98e+08. What is the difference between the highest and the lowest Value added (constant 2005 US$) of Agriculture?
Your answer should be very brief. 5.08e+07. 